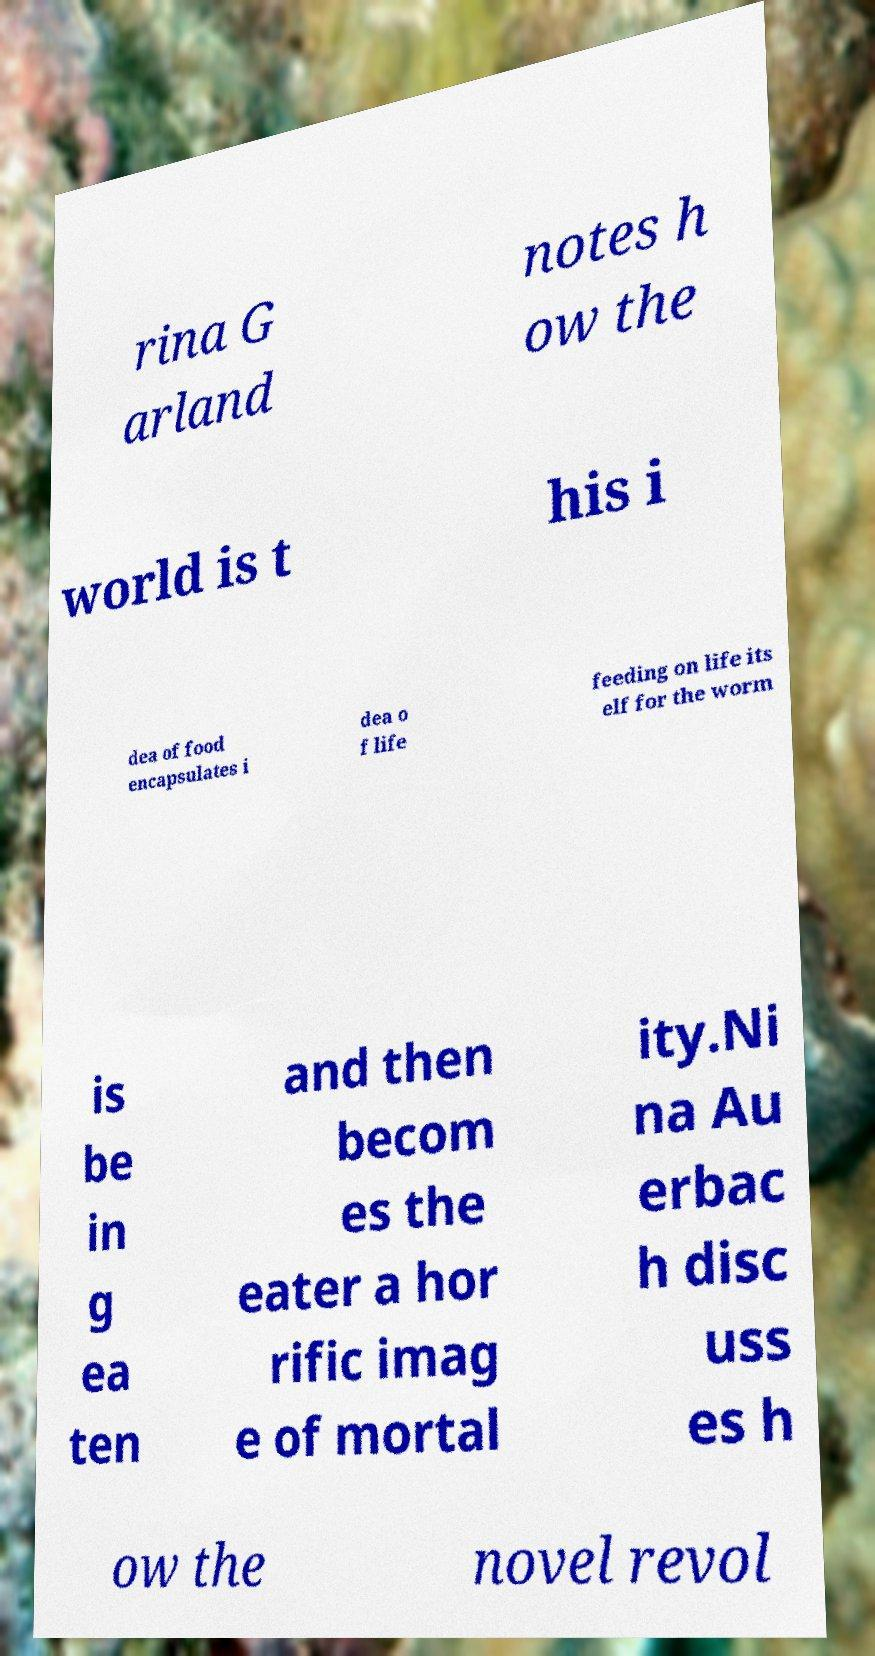Could you assist in decoding the text presented in this image and type it out clearly? rina G arland notes h ow the world is t his i dea of food encapsulates i dea o f life feeding on life its elf for the worm is be in g ea ten and then becom es the eater a hor rific imag e of mortal ity.Ni na Au erbac h disc uss es h ow the novel revol 